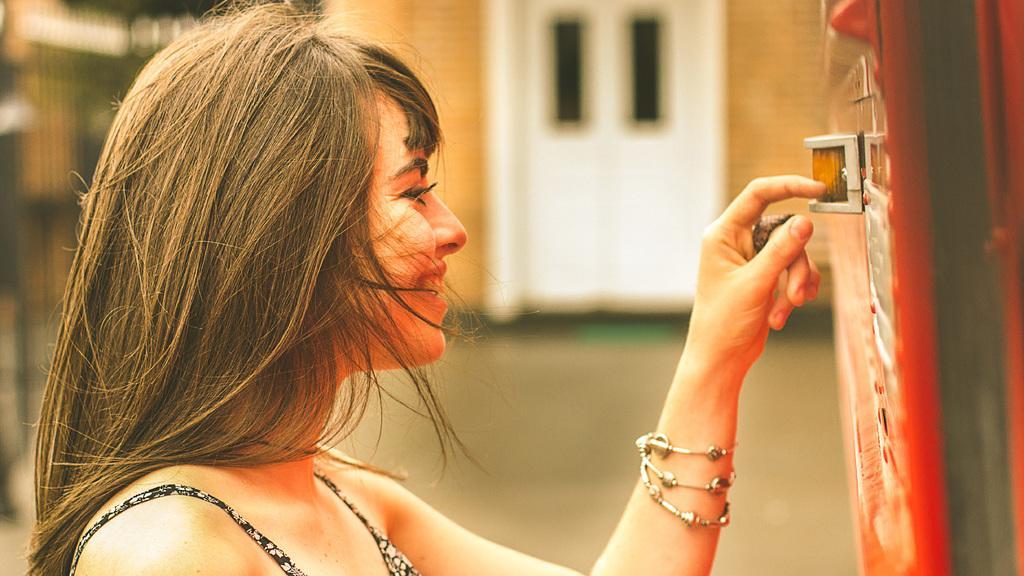How would you summarize this image in a sentence or two? In this image we can see lady. On the right side there is an object. In the back there is a wall with doors. And it is blurry in the background. 